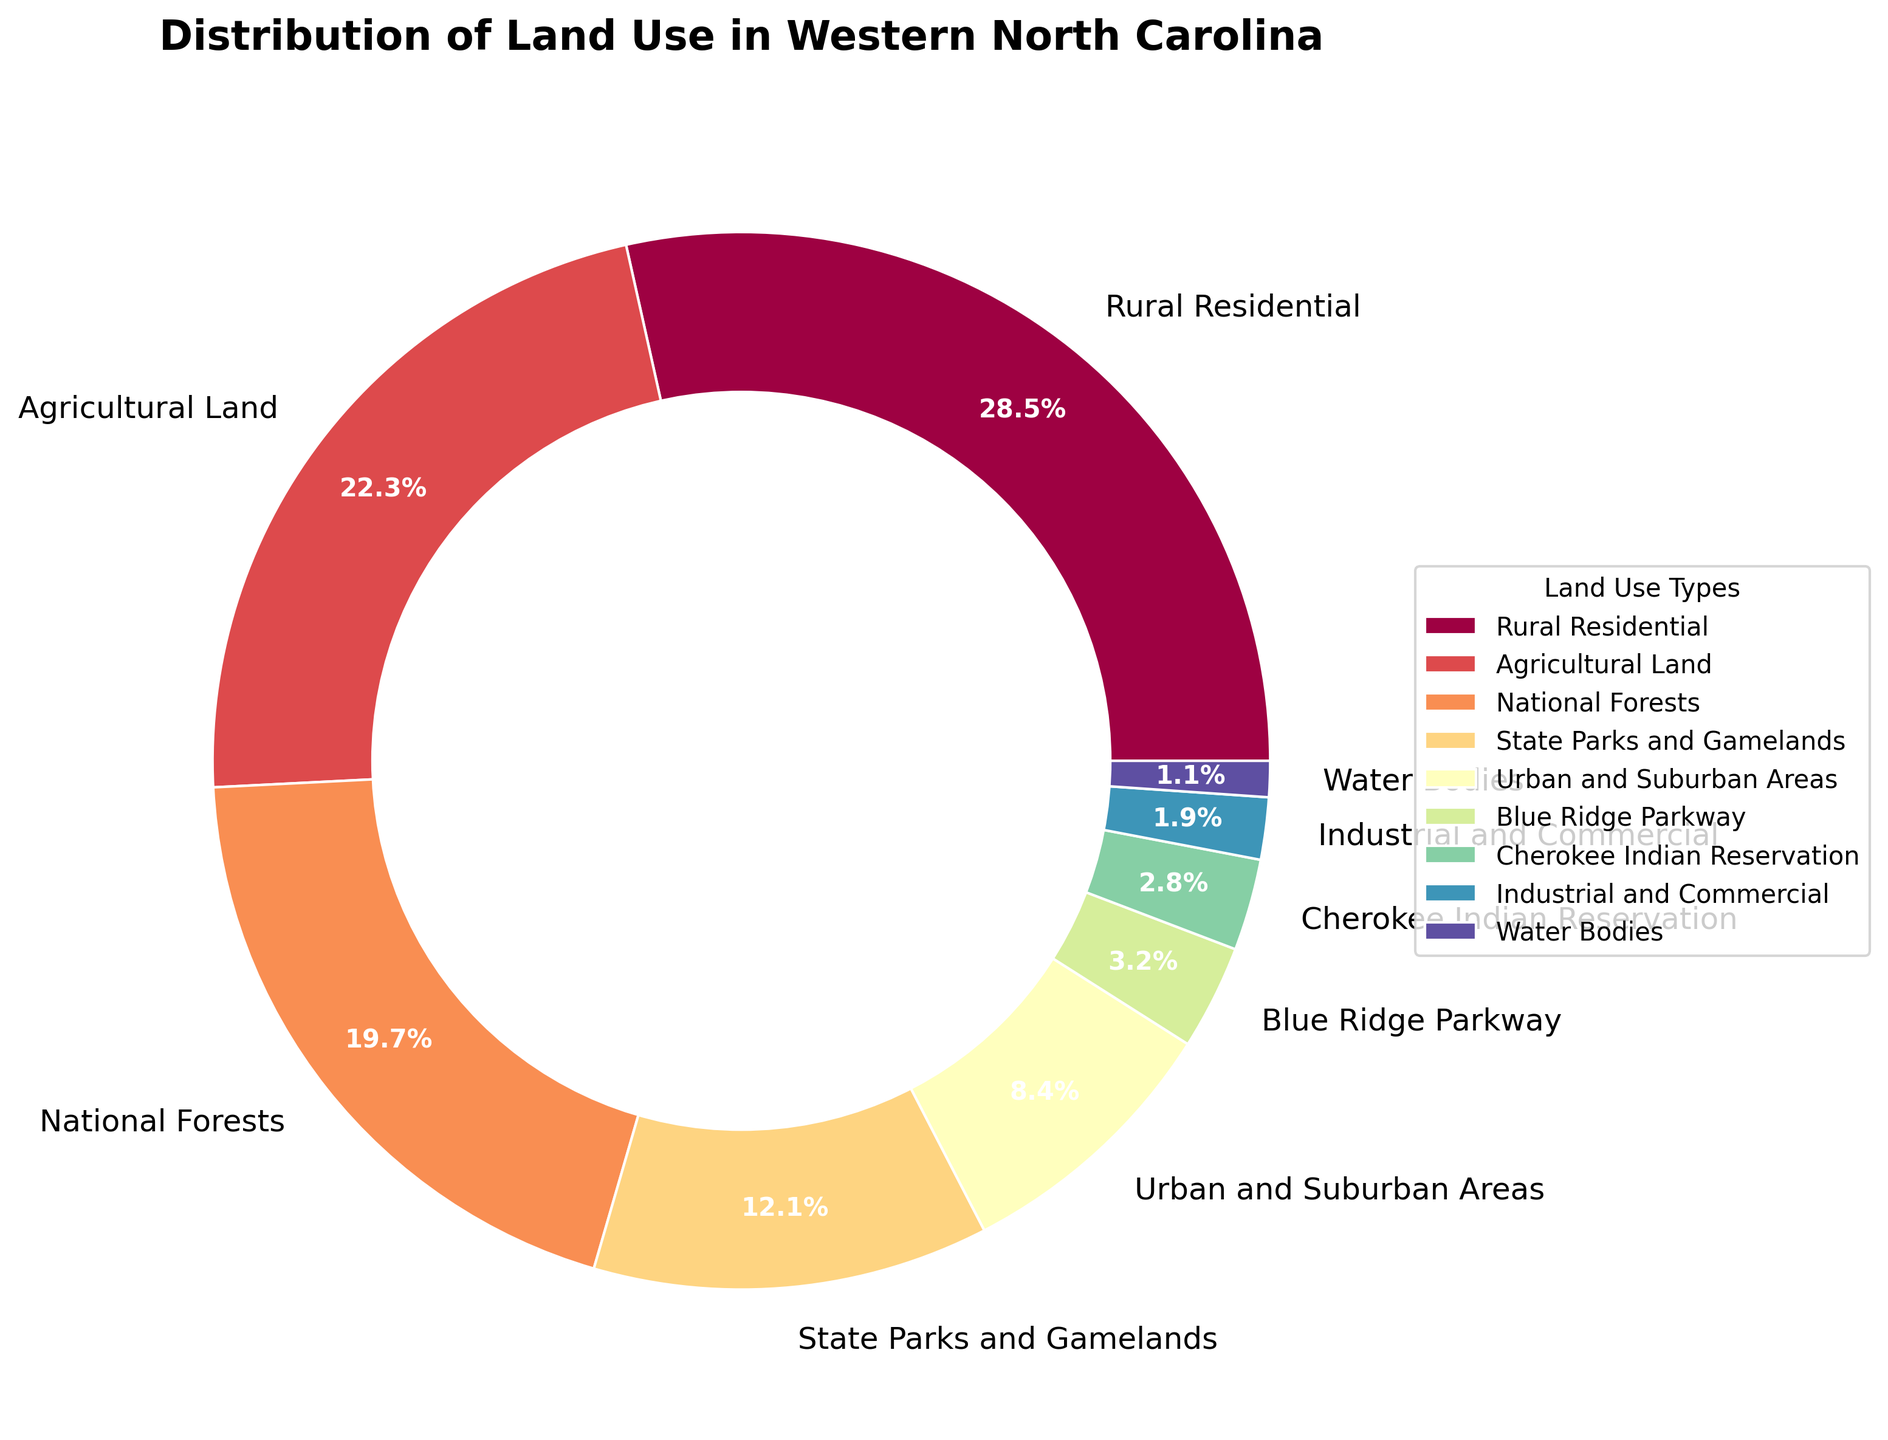Which land use type has the highest percentage? The segment with the highest percentage is labeled "Rural Residential" with a value of 28.5%.
Answer: Rural Residential What are the combined percentages of National Forests and State Parks and Gamelands? The percentage of National Forests is 19.7% and State Parks and Gamelands is 12.1%. Adding these together gives: 19.7 + 12.1 = 31.8%.
Answer: 31.8% Which has a larger area: Urban and Suburban Areas or Agricultural Land? Urban and Suburban Areas have a percentage of 8.4%, while Agricultural Land has a percentage of 22.3%. Since 22.3% is larger than 8.4%, Agricultural Land has a larger area.
Answer: Agricultural Land Is the percentage of Industrial and Commercial land use less than 2%? The percentage of Industrial and Commercial land use is shown as 1.9%, which is less than 2%.
Answer: Yes How does the percentage of Water Bodies compare to Cherokee Indian Reservation? Water Bodies occupy 1.1%, whereas the Cherokee Indian Reservation occupies 2.8%. Since 2.8% is greater than 1.1%, the Cherokee Indian Reservation has a higher percentage.
Answer: The Cherokee Indian Reservation has a higher percentage What is the color associated with Blue Ridge Parkway in the chart? The Blue Ridge Parkway segment is situated within the legend and exhibits a color shade which, while exact nomenclature isn't stipulated, it can be seen directly on the chart.
Answer: (Observe chart directly for color) What is the difference in percentage between Rural Residential and Urban and Suburban Areas? The Rural Residential area is 28.5%, and Urban and Suburban Areas is 8.4%. The difference is 28.5 - 8.4 = 20.1%.
Answer: 20.1% Are the combined percentages of Industrial and Commercial, and Water Bodies greater than 3%? Industrial and Commercial is 1.9%, and Water Bodies is 1.1%. Combined, they total: 1.9 + 1.1 = 3.0%, which is equal to 3%.
Answer: No Which land use type has the smallest percentage? The chart segment with the smallest percentage is labeled "Water Bodies" with a value of 1.1%.
Answer: Water Bodies Does the percentage of Agricultural Land exceed the combined percentage of Blue Ridge Parkway and Cherokee Indian Reservation? Agricultural Land is 22.3%. Blue Ridge Parkway is 3.2%, and Cherokee Indian Reservation is 2.8%. Combined, they total: 3.2 + 2.8 = 6.0%. Since 22.3% is greater than 6.0%, Agricultural Land exceeds the combined percentage.
Answer: Yes 